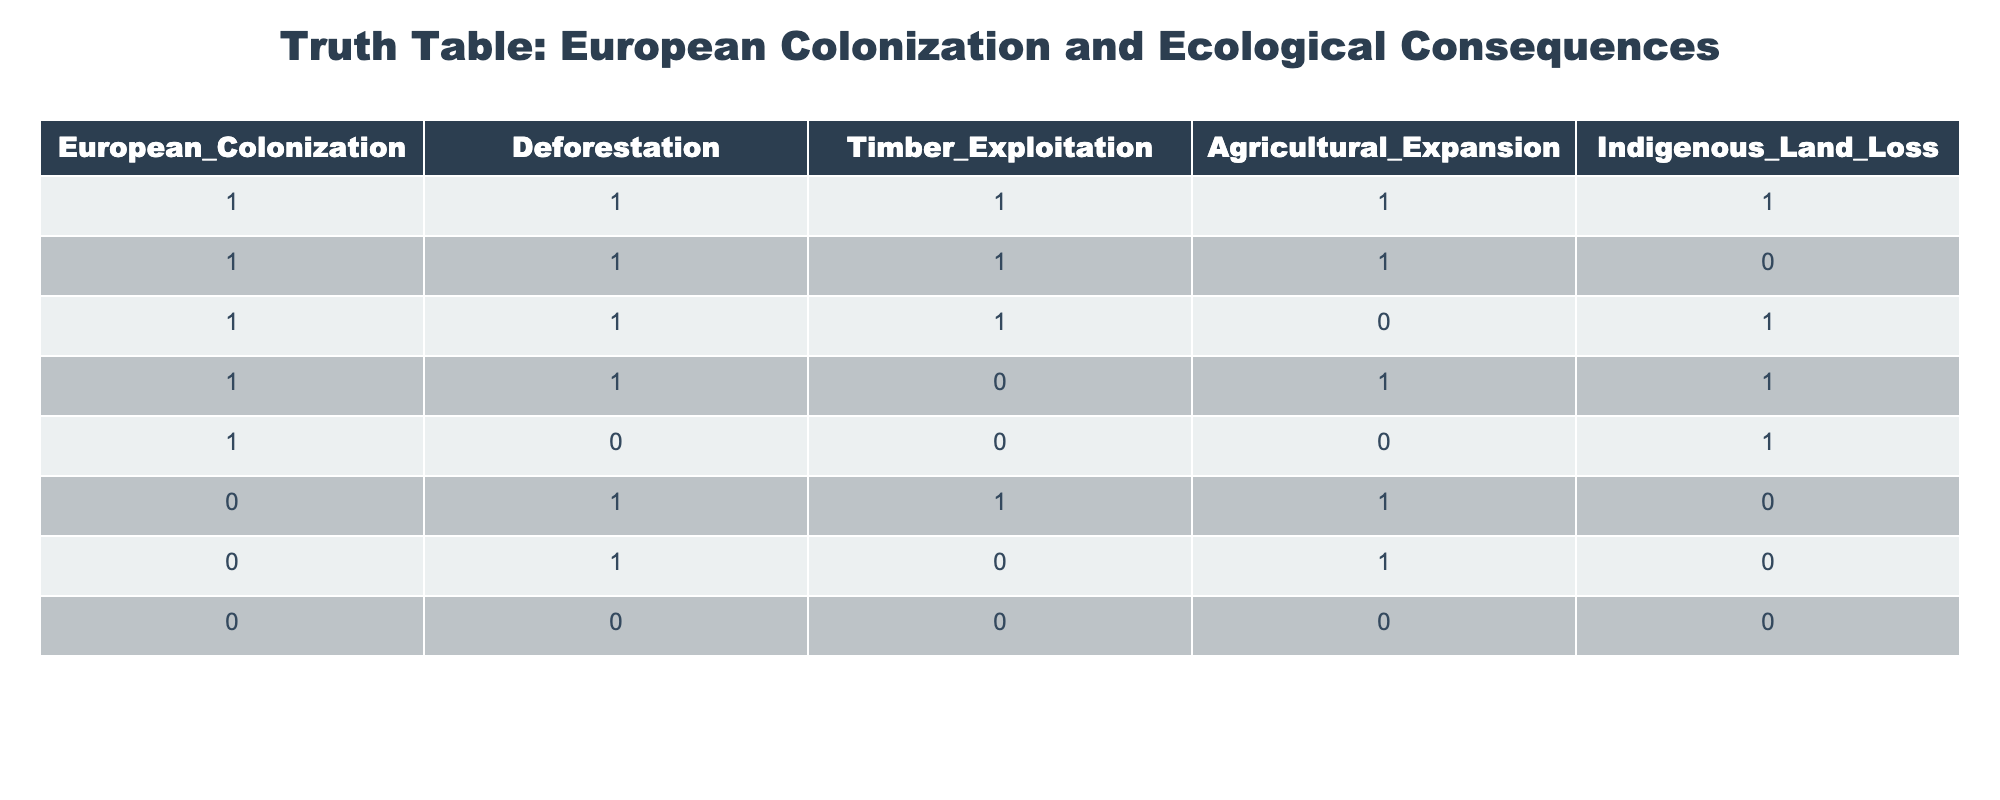What is the total number of instances where European colonization leads to deforestation? There are 5 rows in the table where European colonization (1) is marked, and out of these, all 5 entries also have deforestation (1). Thus, the total number of instances of deforestation resulting from colonization is 5.
Answer: 5 Is there a case where European colonization occurred, but deforestation did not? From the table, there are no instances where European colonization (1) coincides with a lack of deforestation (0). Thus, the answer is no.
Answer: No How many cases show agricultural expansion accompanying deforestation? By examining the rows with deforestation (1), we can spot that in 4 cases, agricultural expansion (1) also occurred. Hence, the answer is 4.
Answer: 4 If we consider instances of indigenous land loss, how many of them also experienced timber exploitation? In the rows where indigenous land loss is marked (1), we find timber exploitation (1) present in 3 of those cases. Thus, the answer is 3.
Answer: 3 What is the relationship between timber exploitation and deforestation when European colonization is absent? There are 3 rows where European colonization is not present (0). Among these, deforestation (1) occurs in 2 instances, both of which also show timber exploitation (1). Hence, the conclusion is that timber exploitation is related to deforestation even in the absence of colonization.
Answer: Yes 